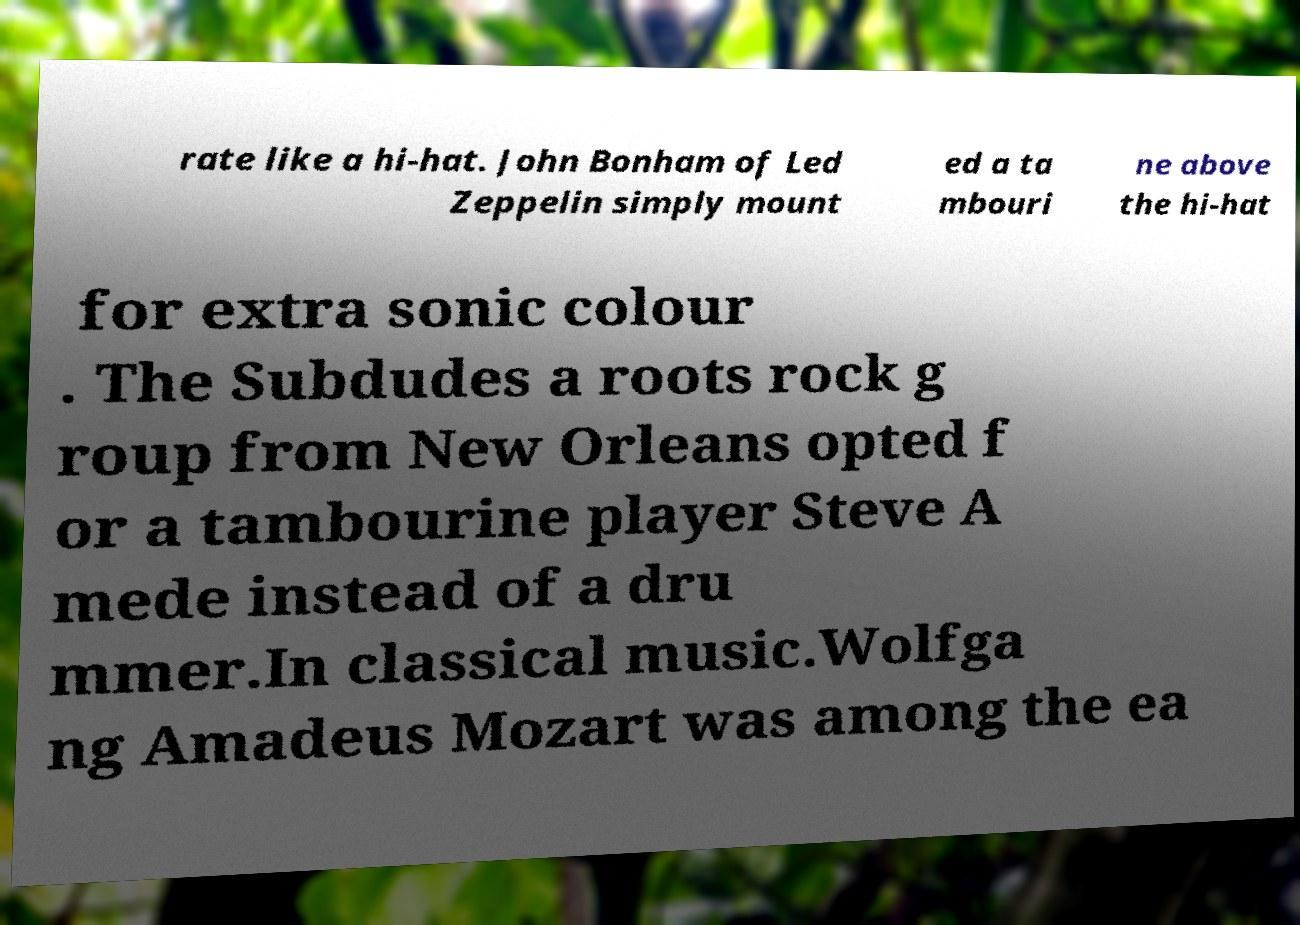Can you read and provide the text displayed in the image?This photo seems to have some interesting text. Can you extract and type it out for me? rate like a hi-hat. John Bonham of Led Zeppelin simply mount ed a ta mbouri ne above the hi-hat for extra sonic colour . The Subdudes a roots rock g roup from New Orleans opted f or a tambourine player Steve A mede instead of a dru mmer.In classical music.Wolfga ng Amadeus Mozart was among the ea 